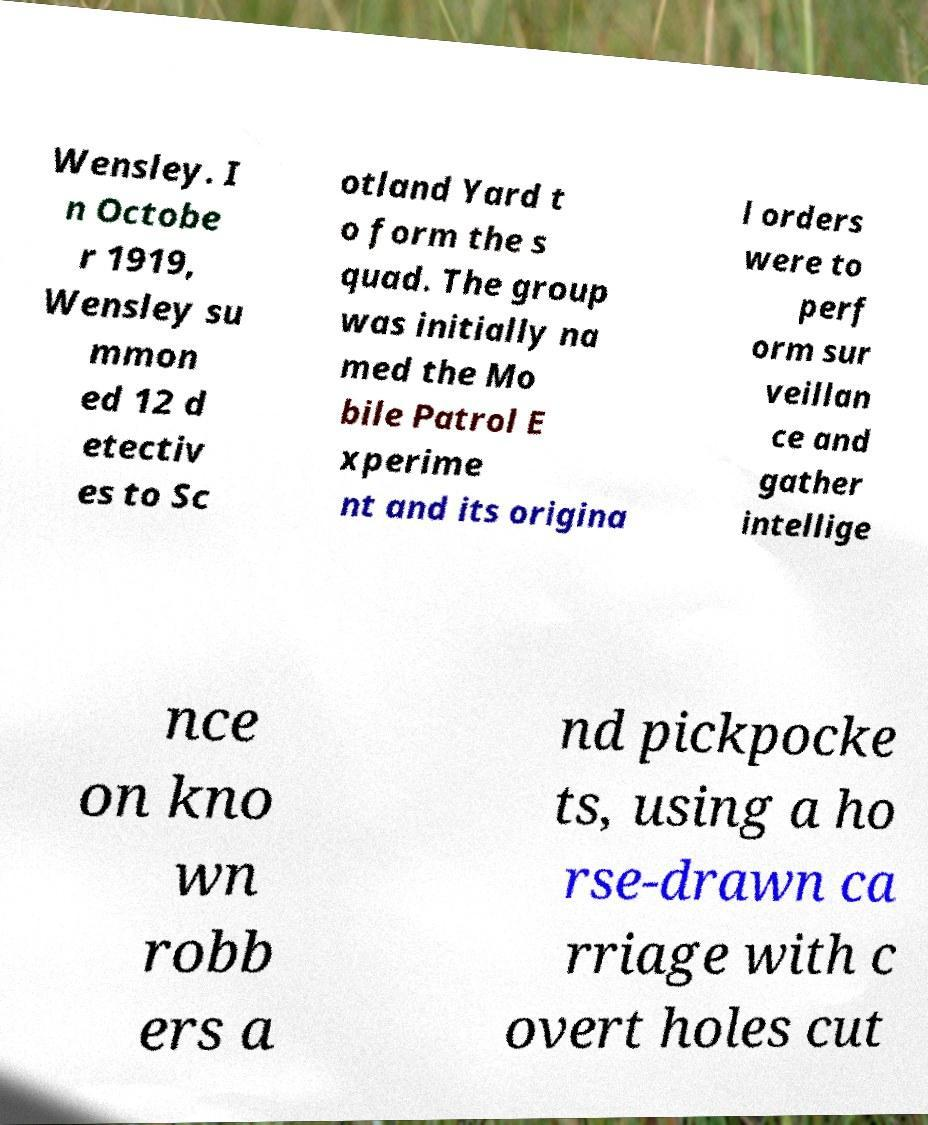I need the written content from this picture converted into text. Can you do that? Wensley. I n Octobe r 1919, Wensley su mmon ed 12 d etectiv es to Sc otland Yard t o form the s quad. The group was initially na med the Mo bile Patrol E xperime nt and its origina l orders were to perf orm sur veillan ce and gather intellige nce on kno wn robb ers a nd pickpocke ts, using a ho rse-drawn ca rriage with c overt holes cut 